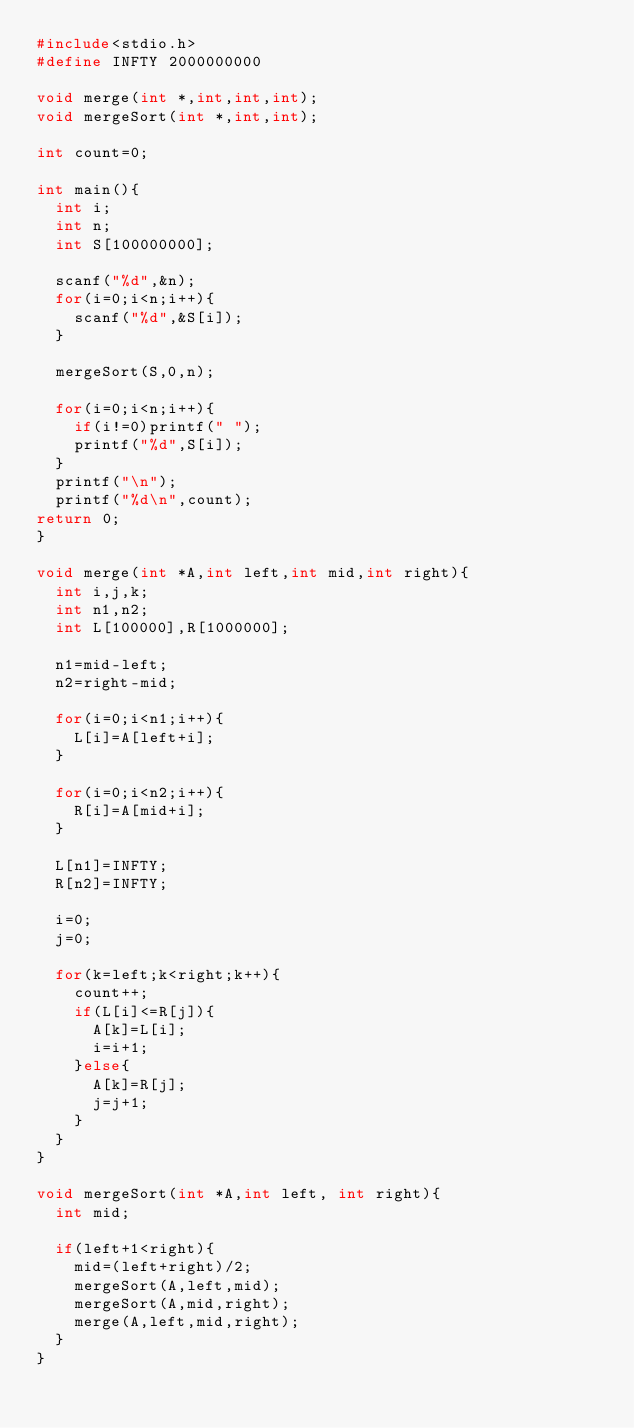<code> <loc_0><loc_0><loc_500><loc_500><_C_>#include<stdio.h>
#define INFTY 2000000000

void merge(int *,int,int,int);
void mergeSort(int *,int,int);

int count=0;

int main(){
  int i;
  int n;
  int S[100000000];

  scanf("%d",&n);
  for(i=0;i<n;i++){
    scanf("%d",&S[i]);
  }

  mergeSort(S,0,n);

  for(i=0;i<n;i++){
    if(i!=0)printf(" ");
    printf("%d",S[i]);
  }
  printf("\n");
  printf("%d\n",count);
return 0;
}

void merge(int *A,int left,int mid,int right){
  int i,j,k;
  int n1,n2;
  int L[100000],R[1000000];

  n1=mid-left;
  n2=right-mid;

  for(i=0;i<n1;i++){
    L[i]=A[left+i];
  }

  for(i=0;i<n2;i++){
    R[i]=A[mid+i];
  }

  L[n1]=INFTY;
  R[n2]=INFTY;

  i=0;
  j=0;

  for(k=left;k<right;k++){
    count++;
    if(L[i]<=R[j]){
      A[k]=L[i];
      i=i+1;
    }else{
      A[k]=R[j];
      j=j+1;
    }
  }
}

void mergeSort(int *A,int left, int right){
  int mid;

  if(left+1<right){
    mid=(left+right)/2;
    mergeSort(A,left,mid);
    mergeSort(A,mid,right);
    merge(A,left,mid,right);
  }
}</code> 